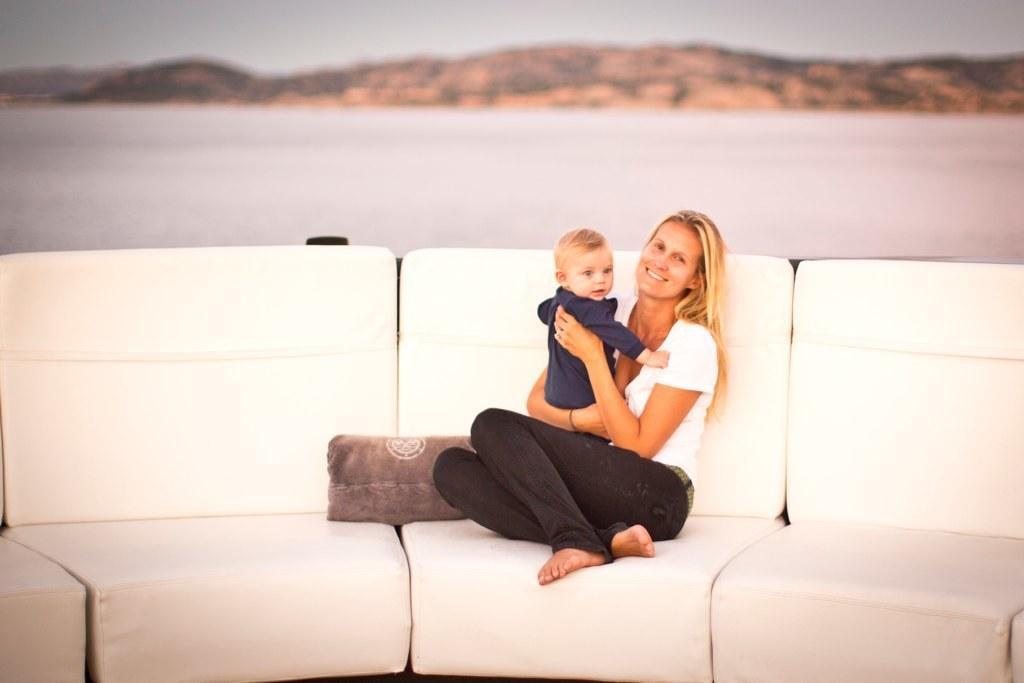Describe this image in one or two sentences. Here I can see a woman carrying a baby in the hands, sitting on a couch, smiling and giving pose for the picture. Beside her I can see a pillow. The couch is in white color. In the background there is a hill. 